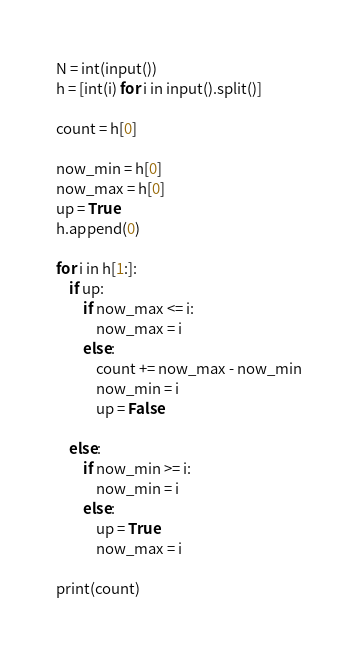Convert code to text. <code><loc_0><loc_0><loc_500><loc_500><_Python_>N = int(input())
h = [int(i) for i in input().split()]

count = h[0]

now_min = h[0]
now_max = h[0]
up = True
h.append(0)

for i in h[1:]:
    if up:
        if now_max <= i:
            now_max = i
        else:
            count += now_max - now_min
            now_min = i
            up = False

    else:
        if now_min >= i:
            now_min = i
        else:
            up = True
            now_max = i

print(count)</code> 